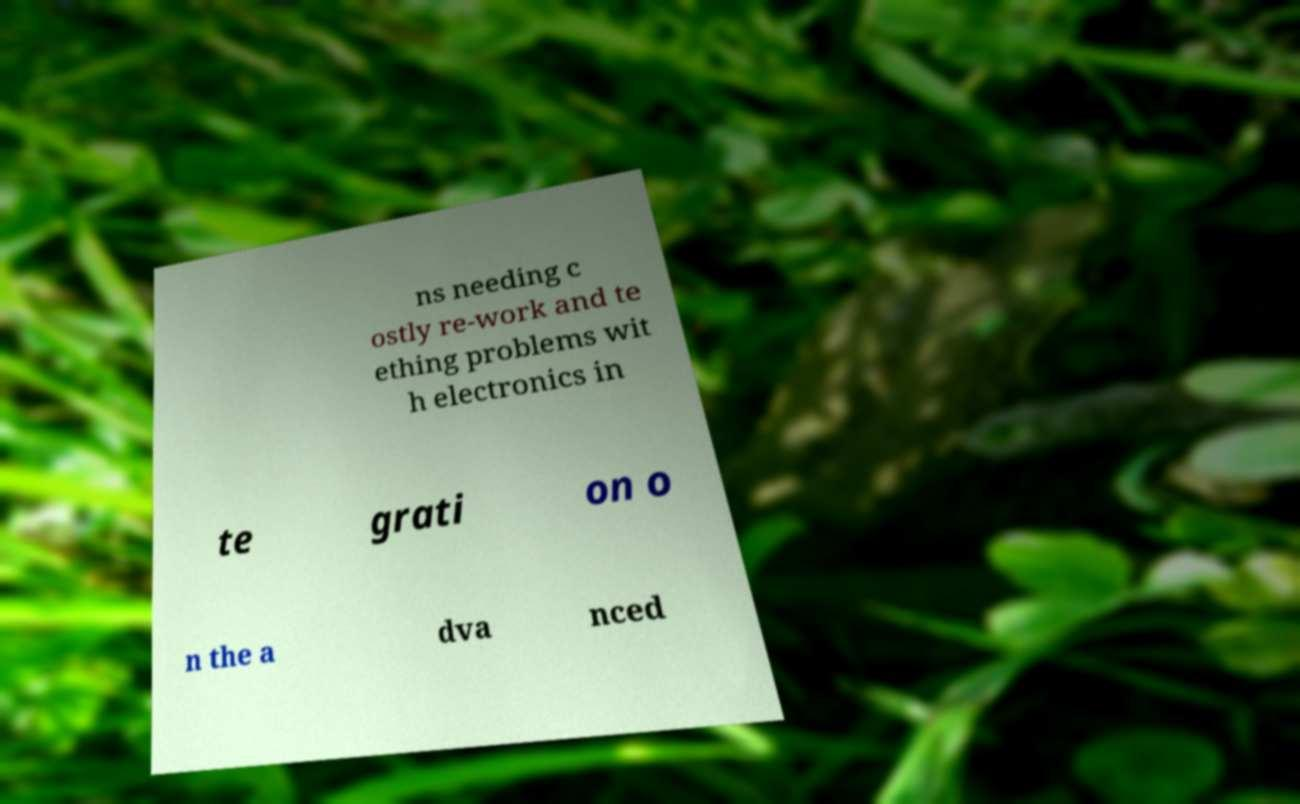There's text embedded in this image that I need extracted. Can you transcribe it verbatim? ns needing c ostly re-work and te ething problems wit h electronics in te grati on o n the a dva nced 